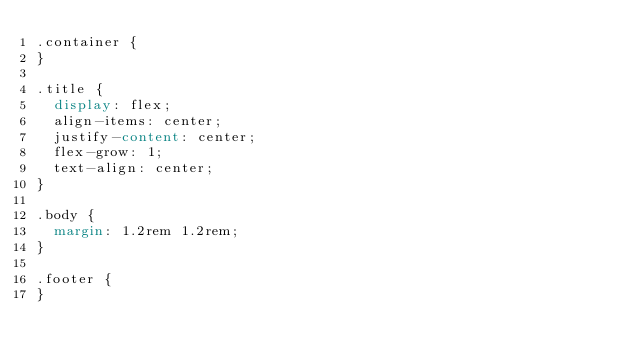<code> <loc_0><loc_0><loc_500><loc_500><_CSS_>.container {
}

.title {
  display: flex;
  align-items: center;
  justify-content: center;
  flex-grow: 1;
  text-align: center;
}

.body {
  margin: 1.2rem 1.2rem;
}

.footer {
}
</code> 